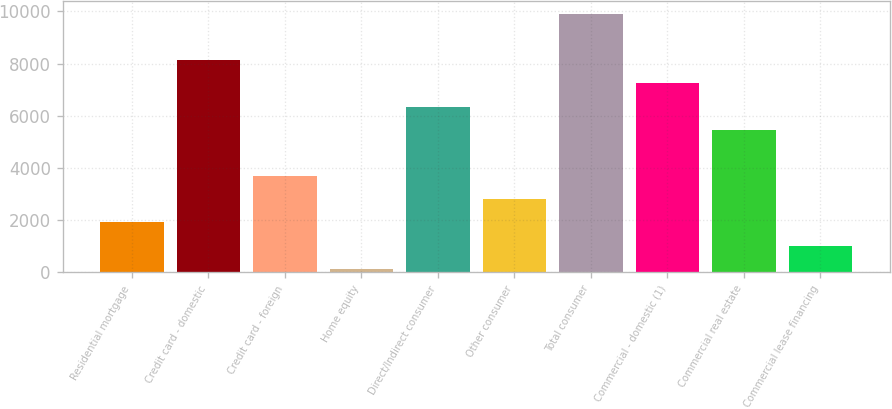Convert chart. <chart><loc_0><loc_0><loc_500><loc_500><bar_chart><fcel>Residential mortgage<fcel>Credit card - domestic<fcel>Credit card - foreign<fcel>Home equity<fcel>Direct/Indirect consumer<fcel>Other consumer<fcel>Total consumer<fcel>Commercial - domestic (1)<fcel>Commercial real estate<fcel>Commercial lease financing<nl><fcel>1909.6<fcel>8127.7<fcel>3686.2<fcel>133<fcel>6351.1<fcel>2797.9<fcel>9904.3<fcel>7239.4<fcel>5462.8<fcel>1021.3<nl></chart> 